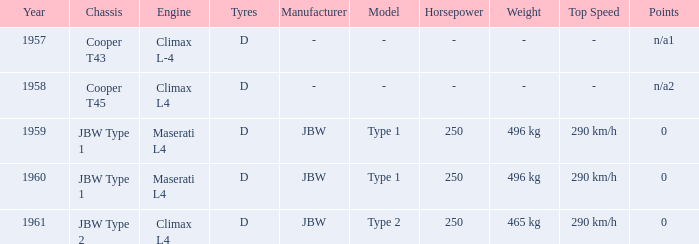Would you be able to parse every entry in this table? {'header': ['Year', 'Chassis', 'Engine', 'Tyres', 'Manufacturer', 'Model', 'Horsepower', 'Weight', 'Top Speed', 'Points'], 'rows': [['1957', 'Cooper T43', 'Climax L-4', 'D', '-', '-', '-', '-', '-', 'n/a1'], ['1958', 'Cooper T45', 'Climax L4', 'D', '-', '-', '-', '-', '-', 'n/a2'], ['1959', 'JBW Type 1', 'Maserati L4', 'D', 'JBW', 'Type 1', '250', '496 kg', '290 km/h', '0'], ['1960', 'JBW Type 1', 'Maserati L4', 'D', 'JBW', 'Type 1', '250', '496 kg', '290 km/h', '0'], ['1961', 'JBW Type 2', 'Climax L4', 'D', 'JBW', 'Type 2', '250', '465 kg', '290 km/h', '0']]} What is the tyres with a year earlier than 1961 for a climax l4 engine? D. 